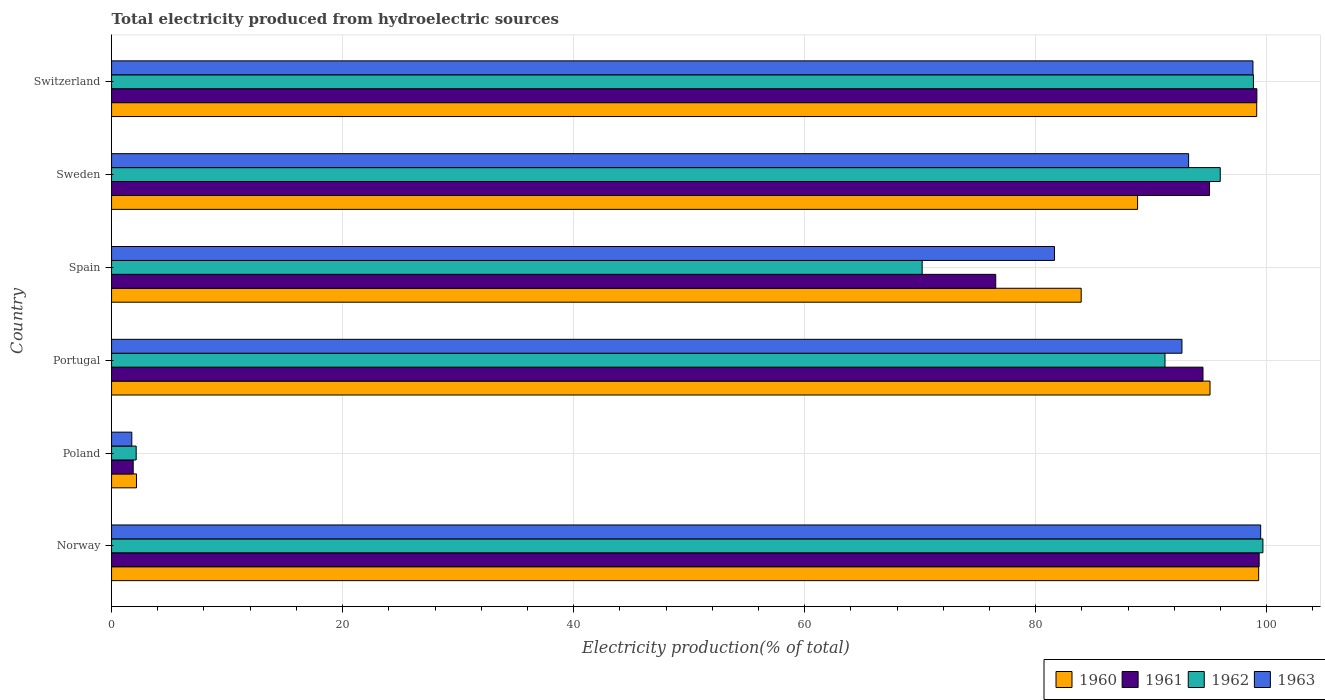How many groups of bars are there?
Ensure brevity in your answer.  6. How many bars are there on the 3rd tick from the top?
Give a very brief answer. 4. What is the label of the 2nd group of bars from the top?
Offer a terse response. Sweden. In how many cases, is the number of bars for a given country not equal to the number of legend labels?
Offer a very short reply. 0. What is the total electricity produced in 1962 in Poland?
Your answer should be compact. 2.13. Across all countries, what is the maximum total electricity produced in 1961?
Your answer should be compact. 99.34. Across all countries, what is the minimum total electricity produced in 1961?
Keep it short and to the point. 1.87. In which country was the total electricity produced in 1962 maximum?
Offer a very short reply. Norway. What is the total total electricity produced in 1961 in the graph?
Provide a short and direct response. 466.43. What is the difference between the total electricity produced in 1962 in Sweden and that in Switzerland?
Your answer should be very brief. -2.87. What is the difference between the total electricity produced in 1962 in Poland and the total electricity produced in 1960 in Spain?
Offer a terse response. -81.8. What is the average total electricity produced in 1961 per country?
Make the answer very short. 77.74. What is the difference between the total electricity produced in 1961 and total electricity produced in 1963 in Spain?
Your answer should be compact. -5.09. In how many countries, is the total electricity produced in 1960 greater than 96 %?
Ensure brevity in your answer.  2. What is the ratio of the total electricity produced in 1963 in Norway to that in Switzerland?
Make the answer very short. 1.01. Is the total electricity produced in 1962 in Poland less than that in Spain?
Give a very brief answer. Yes. What is the difference between the highest and the second highest total electricity produced in 1963?
Keep it short and to the point. 0.67. What is the difference between the highest and the lowest total electricity produced in 1962?
Keep it short and to the point. 97.54. Is it the case that in every country, the sum of the total electricity produced in 1960 and total electricity produced in 1961 is greater than the sum of total electricity produced in 1963 and total electricity produced in 1962?
Give a very brief answer. No. What does the 3rd bar from the bottom in Portugal represents?
Provide a succinct answer. 1962. How many bars are there?
Your answer should be compact. 24. Are all the bars in the graph horizontal?
Give a very brief answer. Yes. What is the difference between two consecutive major ticks on the X-axis?
Provide a succinct answer. 20. Does the graph contain any zero values?
Provide a succinct answer. No. Does the graph contain grids?
Offer a very short reply. Yes. How many legend labels are there?
Make the answer very short. 4. What is the title of the graph?
Your answer should be very brief. Total electricity produced from hydroelectric sources. Does "2011" appear as one of the legend labels in the graph?
Offer a terse response. No. What is the Electricity production(% of total) of 1960 in Norway?
Keep it short and to the point. 99.3. What is the Electricity production(% of total) in 1961 in Norway?
Provide a succinct answer. 99.34. What is the Electricity production(% of total) of 1962 in Norway?
Your answer should be very brief. 99.67. What is the Electricity production(% of total) in 1963 in Norway?
Keep it short and to the point. 99.47. What is the Electricity production(% of total) in 1960 in Poland?
Offer a terse response. 2.16. What is the Electricity production(% of total) in 1961 in Poland?
Ensure brevity in your answer.  1.87. What is the Electricity production(% of total) of 1962 in Poland?
Provide a succinct answer. 2.13. What is the Electricity production(% of total) in 1963 in Poland?
Ensure brevity in your answer.  1.75. What is the Electricity production(% of total) in 1960 in Portugal?
Provide a succinct answer. 95.09. What is the Electricity production(% of total) of 1961 in Portugal?
Provide a succinct answer. 94.48. What is the Electricity production(% of total) in 1962 in Portugal?
Your answer should be compact. 91.19. What is the Electricity production(% of total) of 1963 in Portugal?
Make the answer very short. 92.66. What is the Electricity production(% of total) in 1960 in Spain?
Offer a terse response. 83.94. What is the Electricity production(% of total) of 1961 in Spain?
Your answer should be compact. 76.54. What is the Electricity production(% of total) of 1962 in Spain?
Offer a very short reply. 70.17. What is the Electricity production(% of total) in 1963 in Spain?
Your answer should be very brief. 81.63. What is the Electricity production(% of total) of 1960 in Sweden?
Give a very brief answer. 88.82. What is the Electricity production(% of total) in 1961 in Sweden?
Offer a very short reply. 95.05. What is the Electricity production(% of total) in 1962 in Sweden?
Provide a short and direct response. 95.98. What is the Electricity production(% of total) in 1963 in Sweden?
Ensure brevity in your answer.  93.24. What is the Electricity production(% of total) in 1960 in Switzerland?
Ensure brevity in your answer.  99.13. What is the Electricity production(% of total) in 1961 in Switzerland?
Ensure brevity in your answer.  99.15. What is the Electricity production(% of total) of 1962 in Switzerland?
Your answer should be very brief. 98.85. What is the Electricity production(% of total) of 1963 in Switzerland?
Offer a very short reply. 98.81. Across all countries, what is the maximum Electricity production(% of total) of 1960?
Make the answer very short. 99.3. Across all countries, what is the maximum Electricity production(% of total) in 1961?
Keep it short and to the point. 99.34. Across all countries, what is the maximum Electricity production(% of total) in 1962?
Keep it short and to the point. 99.67. Across all countries, what is the maximum Electricity production(% of total) of 1963?
Provide a succinct answer. 99.47. Across all countries, what is the minimum Electricity production(% of total) of 1960?
Provide a succinct answer. 2.16. Across all countries, what is the minimum Electricity production(% of total) of 1961?
Make the answer very short. 1.87. Across all countries, what is the minimum Electricity production(% of total) in 1962?
Your answer should be compact. 2.13. Across all countries, what is the minimum Electricity production(% of total) of 1963?
Your answer should be compact. 1.75. What is the total Electricity production(% of total) in 1960 in the graph?
Provide a succinct answer. 468.44. What is the total Electricity production(% of total) of 1961 in the graph?
Your response must be concise. 466.43. What is the total Electricity production(% of total) in 1962 in the graph?
Give a very brief answer. 457.99. What is the total Electricity production(% of total) in 1963 in the graph?
Offer a terse response. 467.56. What is the difference between the Electricity production(% of total) of 1960 in Norway and that in Poland?
Offer a very short reply. 97.14. What is the difference between the Electricity production(% of total) in 1961 in Norway and that in Poland?
Your response must be concise. 97.47. What is the difference between the Electricity production(% of total) in 1962 in Norway and that in Poland?
Offer a very short reply. 97.54. What is the difference between the Electricity production(% of total) in 1963 in Norway and that in Poland?
Your answer should be very brief. 97.72. What is the difference between the Electricity production(% of total) of 1960 in Norway and that in Portugal?
Your response must be concise. 4.21. What is the difference between the Electricity production(% of total) of 1961 in Norway and that in Portugal?
Keep it short and to the point. 4.86. What is the difference between the Electricity production(% of total) of 1962 in Norway and that in Portugal?
Your response must be concise. 8.48. What is the difference between the Electricity production(% of total) in 1963 in Norway and that in Portugal?
Keep it short and to the point. 6.81. What is the difference between the Electricity production(% of total) of 1960 in Norway and that in Spain?
Ensure brevity in your answer.  15.36. What is the difference between the Electricity production(% of total) in 1961 in Norway and that in Spain?
Offer a terse response. 22.8. What is the difference between the Electricity production(% of total) in 1962 in Norway and that in Spain?
Your response must be concise. 29.5. What is the difference between the Electricity production(% of total) of 1963 in Norway and that in Spain?
Your answer should be very brief. 17.85. What is the difference between the Electricity production(% of total) of 1960 in Norway and that in Sweden?
Ensure brevity in your answer.  10.48. What is the difference between the Electricity production(% of total) in 1961 in Norway and that in Sweden?
Provide a short and direct response. 4.29. What is the difference between the Electricity production(% of total) in 1962 in Norway and that in Sweden?
Make the answer very short. 3.69. What is the difference between the Electricity production(% of total) in 1963 in Norway and that in Sweden?
Provide a short and direct response. 6.24. What is the difference between the Electricity production(% of total) in 1960 in Norway and that in Switzerland?
Give a very brief answer. 0.17. What is the difference between the Electricity production(% of total) in 1961 in Norway and that in Switzerland?
Your answer should be very brief. 0.2. What is the difference between the Electricity production(% of total) in 1962 in Norway and that in Switzerland?
Offer a very short reply. 0.82. What is the difference between the Electricity production(% of total) in 1963 in Norway and that in Switzerland?
Make the answer very short. 0.67. What is the difference between the Electricity production(% of total) in 1960 in Poland and that in Portugal?
Your answer should be compact. -92.93. What is the difference between the Electricity production(% of total) of 1961 in Poland and that in Portugal?
Make the answer very short. -92.61. What is the difference between the Electricity production(% of total) in 1962 in Poland and that in Portugal?
Give a very brief answer. -89.06. What is the difference between the Electricity production(% of total) of 1963 in Poland and that in Portugal?
Your response must be concise. -90.91. What is the difference between the Electricity production(% of total) of 1960 in Poland and that in Spain?
Provide a succinct answer. -81.78. What is the difference between the Electricity production(% of total) of 1961 in Poland and that in Spain?
Your response must be concise. -74.67. What is the difference between the Electricity production(% of total) in 1962 in Poland and that in Spain?
Offer a terse response. -68.04. What is the difference between the Electricity production(% of total) in 1963 in Poland and that in Spain?
Offer a terse response. -79.88. What is the difference between the Electricity production(% of total) of 1960 in Poland and that in Sweden?
Offer a terse response. -86.66. What is the difference between the Electricity production(% of total) in 1961 in Poland and that in Sweden?
Make the answer very short. -93.17. What is the difference between the Electricity production(% of total) of 1962 in Poland and that in Sweden?
Offer a terse response. -93.84. What is the difference between the Electricity production(% of total) of 1963 in Poland and that in Sweden?
Offer a terse response. -91.48. What is the difference between the Electricity production(% of total) of 1960 in Poland and that in Switzerland?
Keep it short and to the point. -96.97. What is the difference between the Electricity production(% of total) of 1961 in Poland and that in Switzerland?
Offer a terse response. -97.27. What is the difference between the Electricity production(% of total) of 1962 in Poland and that in Switzerland?
Make the answer very short. -96.71. What is the difference between the Electricity production(% of total) of 1963 in Poland and that in Switzerland?
Your answer should be very brief. -97.06. What is the difference between the Electricity production(% of total) of 1960 in Portugal and that in Spain?
Ensure brevity in your answer.  11.15. What is the difference between the Electricity production(% of total) of 1961 in Portugal and that in Spain?
Ensure brevity in your answer.  17.94. What is the difference between the Electricity production(% of total) of 1962 in Portugal and that in Spain?
Provide a short and direct response. 21.02. What is the difference between the Electricity production(% of total) of 1963 in Portugal and that in Spain?
Give a very brief answer. 11.03. What is the difference between the Electricity production(% of total) in 1960 in Portugal and that in Sweden?
Offer a terse response. 6.27. What is the difference between the Electricity production(% of total) in 1961 in Portugal and that in Sweden?
Offer a terse response. -0.57. What is the difference between the Electricity production(% of total) of 1962 in Portugal and that in Sweden?
Your response must be concise. -4.78. What is the difference between the Electricity production(% of total) in 1963 in Portugal and that in Sweden?
Give a very brief answer. -0.58. What is the difference between the Electricity production(% of total) of 1960 in Portugal and that in Switzerland?
Ensure brevity in your answer.  -4.04. What is the difference between the Electricity production(% of total) in 1961 in Portugal and that in Switzerland?
Make the answer very short. -4.67. What is the difference between the Electricity production(% of total) of 1962 in Portugal and that in Switzerland?
Ensure brevity in your answer.  -7.65. What is the difference between the Electricity production(% of total) in 1963 in Portugal and that in Switzerland?
Offer a terse response. -6.15. What is the difference between the Electricity production(% of total) in 1960 in Spain and that in Sweden?
Give a very brief answer. -4.88. What is the difference between the Electricity production(% of total) in 1961 in Spain and that in Sweden?
Your answer should be compact. -18.51. What is the difference between the Electricity production(% of total) of 1962 in Spain and that in Sweden?
Keep it short and to the point. -25.8. What is the difference between the Electricity production(% of total) of 1963 in Spain and that in Sweden?
Offer a very short reply. -11.61. What is the difference between the Electricity production(% of total) in 1960 in Spain and that in Switzerland?
Provide a succinct answer. -15.19. What is the difference between the Electricity production(% of total) in 1961 in Spain and that in Switzerland?
Offer a very short reply. -22.61. What is the difference between the Electricity production(% of total) of 1962 in Spain and that in Switzerland?
Keep it short and to the point. -28.67. What is the difference between the Electricity production(% of total) in 1963 in Spain and that in Switzerland?
Make the answer very short. -17.18. What is the difference between the Electricity production(% of total) in 1960 in Sweden and that in Switzerland?
Provide a succinct answer. -10.31. What is the difference between the Electricity production(% of total) of 1961 in Sweden and that in Switzerland?
Make the answer very short. -4.1. What is the difference between the Electricity production(% of total) of 1962 in Sweden and that in Switzerland?
Your response must be concise. -2.87. What is the difference between the Electricity production(% of total) of 1963 in Sweden and that in Switzerland?
Provide a short and direct response. -5.57. What is the difference between the Electricity production(% of total) in 1960 in Norway and the Electricity production(% of total) in 1961 in Poland?
Give a very brief answer. 97.43. What is the difference between the Electricity production(% of total) in 1960 in Norway and the Electricity production(% of total) in 1962 in Poland?
Provide a succinct answer. 97.17. What is the difference between the Electricity production(% of total) of 1960 in Norway and the Electricity production(% of total) of 1963 in Poland?
Provide a succinct answer. 97.55. What is the difference between the Electricity production(% of total) of 1961 in Norway and the Electricity production(% of total) of 1962 in Poland?
Offer a terse response. 97.21. What is the difference between the Electricity production(% of total) of 1961 in Norway and the Electricity production(% of total) of 1963 in Poland?
Offer a very short reply. 97.59. What is the difference between the Electricity production(% of total) of 1962 in Norway and the Electricity production(% of total) of 1963 in Poland?
Your answer should be compact. 97.92. What is the difference between the Electricity production(% of total) of 1960 in Norway and the Electricity production(% of total) of 1961 in Portugal?
Give a very brief answer. 4.82. What is the difference between the Electricity production(% of total) in 1960 in Norway and the Electricity production(% of total) in 1962 in Portugal?
Give a very brief answer. 8.11. What is the difference between the Electricity production(% of total) in 1960 in Norway and the Electricity production(% of total) in 1963 in Portugal?
Provide a short and direct response. 6.64. What is the difference between the Electricity production(% of total) of 1961 in Norway and the Electricity production(% of total) of 1962 in Portugal?
Your response must be concise. 8.15. What is the difference between the Electricity production(% of total) in 1961 in Norway and the Electricity production(% of total) in 1963 in Portugal?
Provide a succinct answer. 6.68. What is the difference between the Electricity production(% of total) of 1962 in Norway and the Electricity production(% of total) of 1963 in Portugal?
Make the answer very short. 7.01. What is the difference between the Electricity production(% of total) in 1960 in Norway and the Electricity production(% of total) in 1961 in Spain?
Offer a terse response. 22.76. What is the difference between the Electricity production(% of total) of 1960 in Norway and the Electricity production(% of total) of 1962 in Spain?
Provide a succinct answer. 29.13. What is the difference between the Electricity production(% of total) of 1960 in Norway and the Electricity production(% of total) of 1963 in Spain?
Provide a succinct answer. 17.67. What is the difference between the Electricity production(% of total) of 1961 in Norway and the Electricity production(% of total) of 1962 in Spain?
Offer a very short reply. 29.17. What is the difference between the Electricity production(% of total) of 1961 in Norway and the Electricity production(% of total) of 1963 in Spain?
Give a very brief answer. 17.72. What is the difference between the Electricity production(% of total) of 1962 in Norway and the Electricity production(% of total) of 1963 in Spain?
Make the answer very short. 18.04. What is the difference between the Electricity production(% of total) of 1960 in Norway and the Electricity production(% of total) of 1961 in Sweden?
Give a very brief answer. 4.25. What is the difference between the Electricity production(% of total) in 1960 in Norway and the Electricity production(% of total) in 1962 in Sweden?
Ensure brevity in your answer.  3.33. What is the difference between the Electricity production(% of total) of 1960 in Norway and the Electricity production(% of total) of 1963 in Sweden?
Offer a very short reply. 6.06. What is the difference between the Electricity production(% of total) in 1961 in Norway and the Electricity production(% of total) in 1962 in Sweden?
Provide a succinct answer. 3.37. What is the difference between the Electricity production(% of total) in 1961 in Norway and the Electricity production(% of total) in 1963 in Sweden?
Your answer should be compact. 6.11. What is the difference between the Electricity production(% of total) in 1962 in Norway and the Electricity production(% of total) in 1963 in Sweden?
Your response must be concise. 6.43. What is the difference between the Electricity production(% of total) of 1960 in Norway and the Electricity production(% of total) of 1961 in Switzerland?
Your answer should be compact. 0.15. What is the difference between the Electricity production(% of total) of 1960 in Norway and the Electricity production(% of total) of 1962 in Switzerland?
Make the answer very short. 0.45. What is the difference between the Electricity production(% of total) of 1960 in Norway and the Electricity production(% of total) of 1963 in Switzerland?
Give a very brief answer. 0.49. What is the difference between the Electricity production(% of total) of 1961 in Norway and the Electricity production(% of total) of 1962 in Switzerland?
Your response must be concise. 0.5. What is the difference between the Electricity production(% of total) of 1961 in Norway and the Electricity production(% of total) of 1963 in Switzerland?
Your response must be concise. 0.54. What is the difference between the Electricity production(% of total) in 1962 in Norway and the Electricity production(% of total) in 1963 in Switzerland?
Your answer should be compact. 0.86. What is the difference between the Electricity production(% of total) of 1960 in Poland and the Electricity production(% of total) of 1961 in Portugal?
Your answer should be very brief. -92.32. What is the difference between the Electricity production(% of total) in 1960 in Poland and the Electricity production(% of total) in 1962 in Portugal?
Your answer should be compact. -89.03. What is the difference between the Electricity production(% of total) in 1960 in Poland and the Electricity production(% of total) in 1963 in Portugal?
Provide a short and direct response. -90.5. What is the difference between the Electricity production(% of total) of 1961 in Poland and the Electricity production(% of total) of 1962 in Portugal?
Make the answer very short. -89.32. What is the difference between the Electricity production(% of total) in 1961 in Poland and the Electricity production(% of total) in 1963 in Portugal?
Offer a very short reply. -90.79. What is the difference between the Electricity production(% of total) of 1962 in Poland and the Electricity production(% of total) of 1963 in Portugal?
Your answer should be compact. -90.53. What is the difference between the Electricity production(% of total) of 1960 in Poland and the Electricity production(% of total) of 1961 in Spain?
Ensure brevity in your answer.  -74.38. What is the difference between the Electricity production(% of total) of 1960 in Poland and the Electricity production(% of total) of 1962 in Spain?
Your answer should be very brief. -68.01. What is the difference between the Electricity production(% of total) of 1960 in Poland and the Electricity production(% of total) of 1963 in Spain?
Provide a succinct answer. -79.47. What is the difference between the Electricity production(% of total) of 1961 in Poland and the Electricity production(% of total) of 1962 in Spain?
Give a very brief answer. -68.3. What is the difference between the Electricity production(% of total) of 1961 in Poland and the Electricity production(% of total) of 1963 in Spain?
Offer a very short reply. -79.75. What is the difference between the Electricity production(% of total) of 1962 in Poland and the Electricity production(% of total) of 1963 in Spain?
Provide a succinct answer. -79.5. What is the difference between the Electricity production(% of total) in 1960 in Poland and the Electricity production(% of total) in 1961 in Sweden?
Keep it short and to the point. -92.89. What is the difference between the Electricity production(% of total) of 1960 in Poland and the Electricity production(% of total) of 1962 in Sweden?
Your answer should be very brief. -93.82. What is the difference between the Electricity production(% of total) in 1960 in Poland and the Electricity production(% of total) in 1963 in Sweden?
Make the answer very short. -91.08. What is the difference between the Electricity production(% of total) in 1961 in Poland and the Electricity production(% of total) in 1962 in Sweden?
Give a very brief answer. -94.1. What is the difference between the Electricity production(% of total) of 1961 in Poland and the Electricity production(% of total) of 1963 in Sweden?
Provide a short and direct response. -91.36. What is the difference between the Electricity production(% of total) of 1962 in Poland and the Electricity production(% of total) of 1963 in Sweden?
Offer a terse response. -91.1. What is the difference between the Electricity production(% of total) in 1960 in Poland and the Electricity production(% of total) in 1961 in Switzerland?
Provide a succinct answer. -96.99. What is the difference between the Electricity production(% of total) in 1960 in Poland and the Electricity production(% of total) in 1962 in Switzerland?
Ensure brevity in your answer.  -96.69. What is the difference between the Electricity production(% of total) in 1960 in Poland and the Electricity production(% of total) in 1963 in Switzerland?
Provide a short and direct response. -96.65. What is the difference between the Electricity production(% of total) of 1961 in Poland and the Electricity production(% of total) of 1962 in Switzerland?
Your response must be concise. -96.97. What is the difference between the Electricity production(% of total) in 1961 in Poland and the Electricity production(% of total) in 1963 in Switzerland?
Keep it short and to the point. -96.93. What is the difference between the Electricity production(% of total) in 1962 in Poland and the Electricity production(% of total) in 1963 in Switzerland?
Offer a terse response. -96.67. What is the difference between the Electricity production(% of total) in 1960 in Portugal and the Electricity production(% of total) in 1961 in Spain?
Keep it short and to the point. 18.55. What is the difference between the Electricity production(% of total) in 1960 in Portugal and the Electricity production(% of total) in 1962 in Spain?
Give a very brief answer. 24.92. What is the difference between the Electricity production(% of total) of 1960 in Portugal and the Electricity production(% of total) of 1963 in Spain?
Offer a very short reply. 13.46. What is the difference between the Electricity production(% of total) in 1961 in Portugal and the Electricity production(% of total) in 1962 in Spain?
Provide a succinct answer. 24.31. What is the difference between the Electricity production(% of total) of 1961 in Portugal and the Electricity production(% of total) of 1963 in Spain?
Your answer should be compact. 12.85. What is the difference between the Electricity production(% of total) in 1962 in Portugal and the Electricity production(% of total) in 1963 in Spain?
Provide a short and direct response. 9.57. What is the difference between the Electricity production(% of total) in 1960 in Portugal and the Electricity production(% of total) in 1961 in Sweden?
Make the answer very short. 0.04. What is the difference between the Electricity production(% of total) in 1960 in Portugal and the Electricity production(% of total) in 1962 in Sweden?
Ensure brevity in your answer.  -0.89. What is the difference between the Electricity production(% of total) of 1960 in Portugal and the Electricity production(% of total) of 1963 in Sweden?
Your answer should be very brief. 1.85. What is the difference between the Electricity production(% of total) of 1961 in Portugal and the Electricity production(% of total) of 1962 in Sweden?
Make the answer very short. -1.49. What is the difference between the Electricity production(% of total) in 1961 in Portugal and the Electricity production(% of total) in 1963 in Sweden?
Offer a very short reply. 1.24. What is the difference between the Electricity production(% of total) of 1962 in Portugal and the Electricity production(% of total) of 1963 in Sweden?
Keep it short and to the point. -2.04. What is the difference between the Electricity production(% of total) in 1960 in Portugal and the Electricity production(% of total) in 1961 in Switzerland?
Provide a short and direct response. -4.06. What is the difference between the Electricity production(% of total) in 1960 in Portugal and the Electricity production(% of total) in 1962 in Switzerland?
Provide a succinct answer. -3.76. What is the difference between the Electricity production(% of total) in 1960 in Portugal and the Electricity production(% of total) in 1963 in Switzerland?
Offer a very short reply. -3.72. What is the difference between the Electricity production(% of total) in 1961 in Portugal and the Electricity production(% of total) in 1962 in Switzerland?
Keep it short and to the point. -4.37. What is the difference between the Electricity production(% of total) in 1961 in Portugal and the Electricity production(% of total) in 1963 in Switzerland?
Ensure brevity in your answer.  -4.33. What is the difference between the Electricity production(% of total) in 1962 in Portugal and the Electricity production(% of total) in 1963 in Switzerland?
Offer a terse response. -7.61. What is the difference between the Electricity production(% of total) in 1960 in Spain and the Electricity production(% of total) in 1961 in Sweden?
Offer a terse response. -11.11. What is the difference between the Electricity production(% of total) of 1960 in Spain and the Electricity production(% of total) of 1962 in Sweden?
Make the answer very short. -12.04. What is the difference between the Electricity production(% of total) of 1960 in Spain and the Electricity production(% of total) of 1963 in Sweden?
Ensure brevity in your answer.  -9.3. What is the difference between the Electricity production(% of total) of 1961 in Spain and the Electricity production(% of total) of 1962 in Sweden?
Your answer should be compact. -19.44. What is the difference between the Electricity production(% of total) in 1961 in Spain and the Electricity production(% of total) in 1963 in Sweden?
Your response must be concise. -16.7. What is the difference between the Electricity production(% of total) of 1962 in Spain and the Electricity production(% of total) of 1963 in Sweden?
Offer a terse response. -23.06. What is the difference between the Electricity production(% of total) of 1960 in Spain and the Electricity production(% of total) of 1961 in Switzerland?
Your response must be concise. -15.21. What is the difference between the Electricity production(% of total) in 1960 in Spain and the Electricity production(% of total) in 1962 in Switzerland?
Make the answer very short. -14.91. What is the difference between the Electricity production(% of total) of 1960 in Spain and the Electricity production(% of total) of 1963 in Switzerland?
Provide a short and direct response. -14.87. What is the difference between the Electricity production(% of total) in 1961 in Spain and the Electricity production(% of total) in 1962 in Switzerland?
Make the answer very short. -22.31. What is the difference between the Electricity production(% of total) in 1961 in Spain and the Electricity production(% of total) in 1963 in Switzerland?
Offer a very short reply. -22.27. What is the difference between the Electricity production(% of total) of 1962 in Spain and the Electricity production(% of total) of 1963 in Switzerland?
Your response must be concise. -28.63. What is the difference between the Electricity production(% of total) of 1960 in Sweden and the Electricity production(% of total) of 1961 in Switzerland?
Offer a terse response. -10.33. What is the difference between the Electricity production(% of total) of 1960 in Sweden and the Electricity production(% of total) of 1962 in Switzerland?
Offer a very short reply. -10.03. What is the difference between the Electricity production(% of total) in 1960 in Sweden and the Electricity production(% of total) in 1963 in Switzerland?
Provide a succinct answer. -9.99. What is the difference between the Electricity production(% of total) of 1961 in Sweden and the Electricity production(% of total) of 1962 in Switzerland?
Give a very brief answer. -3.8. What is the difference between the Electricity production(% of total) in 1961 in Sweden and the Electricity production(% of total) in 1963 in Switzerland?
Keep it short and to the point. -3.76. What is the difference between the Electricity production(% of total) in 1962 in Sweden and the Electricity production(% of total) in 1963 in Switzerland?
Keep it short and to the point. -2.83. What is the average Electricity production(% of total) in 1960 per country?
Your answer should be compact. 78.07. What is the average Electricity production(% of total) in 1961 per country?
Ensure brevity in your answer.  77.74. What is the average Electricity production(% of total) in 1962 per country?
Your answer should be compact. 76.33. What is the average Electricity production(% of total) of 1963 per country?
Keep it short and to the point. 77.93. What is the difference between the Electricity production(% of total) in 1960 and Electricity production(% of total) in 1961 in Norway?
Ensure brevity in your answer.  -0.04. What is the difference between the Electricity production(% of total) in 1960 and Electricity production(% of total) in 1962 in Norway?
Provide a short and direct response. -0.37. What is the difference between the Electricity production(% of total) of 1960 and Electricity production(% of total) of 1963 in Norway?
Ensure brevity in your answer.  -0.17. What is the difference between the Electricity production(% of total) of 1961 and Electricity production(% of total) of 1962 in Norway?
Ensure brevity in your answer.  -0.33. What is the difference between the Electricity production(% of total) of 1961 and Electricity production(% of total) of 1963 in Norway?
Your response must be concise. -0.13. What is the difference between the Electricity production(% of total) of 1962 and Electricity production(% of total) of 1963 in Norway?
Keep it short and to the point. 0.19. What is the difference between the Electricity production(% of total) in 1960 and Electricity production(% of total) in 1961 in Poland?
Provide a short and direct response. 0.28. What is the difference between the Electricity production(% of total) in 1960 and Electricity production(% of total) in 1962 in Poland?
Your answer should be very brief. 0.03. What is the difference between the Electricity production(% of total) of 1960 and Electricity production(% of total) of 1963 in Poland?
Keep it short and to the point. 0.41. What is the difference between the Electricity production(% of total) in 1961 and Electricity production(% of total) in 1962 in Poland?
Your answer should be very brief. -0.26. What is the difference between the Electricity production(% of total) in 1961 and Electricity production(% of total) in 1963 in Poland?
Provide a short and direct response. 0.12. What is the difference between the Electricity production(% of total) in 1962 and Electricity production(% of total) in 1963 in Poland?
Keep it short and to the point. 0.38. What is the difference between the Electricity production(% of total) of 1960 and Electricity production(% of total) of 1961 in Portugal?
Offer a very short reply. 0.61. What is the difference between the Electricity production(% of total) of 1960 and Electricity production(% of total) of 1962 in Portugal?
Provide a short and direct response. 3.9. What is the difference between the Electricity production(% of total) in 1960 and Electricity production(% of total) in 1963 in Portugal?
Keep it short and to the point. 2.43. What is the difference between the Electricity production(% of total) of 1961 and Electricity production(% of total) of 1962 in Portugal?
Ensure brevity in your answer.  3.29. What is the difference between the Electricity production(% of total) in 1961 and Electricity production(% of total) in 1963 in Portugal?
Ensure brevity in your answer.  1.82. What is the difference between the Electricity production(% of total) in 1962 and Electricity production(% of total) in 1963 in Portugal?
Give a very brief answer. -1.47. What is the difference between the Electricity production(% of total) in 1960 and Electricity production(% of total) in 1961 in Spain?
Provide a succinct answer. 7.4. What is the difference between the Electricity production(% of total) in 1960 and Electricity production(% of total) in 1962 in Spain?
Give a very brief answer. 13.76. What is the difference between the Electricity production(% of total) of 1960 and Electricity production(% of total) of 1963 in Spain?
Provide a short and direct response. 2.31. What is the difference between the Electricity production(% of total) of 1961 and Electricity production(% of total) of 1962 in Spain?
Give a very brief answer. 6.37. What is the difference between the Electricity production(% of total) of 1961 and Electricity production(% of total) of 1963 in Spain?
Ensure brevity in your answer.  -5.09. What is the difference between the Electricity production(% of total) of 1962 and Electricity production(% of total) of 1963 in Spain?
Keep it short and to the point. -11.45. What is the difference between the Electricity production(% of total) in 1960 and Electricity production(% of total) in 1961 in Sweden?
Ensure brevity in your answer.  -6.23. What is the difference between the Electricity production(% of total) in 1960 and Electricity production(% of total) in 1962 in Sweden?
Offer a terse response. -7.16. What is the difference between the Electricity production(% of total) in 1960 and Electricity production(% of total) in 1963 in Sweden?
Ensure brevity in your answer.  -4.42. What is the difference between the Electricity production(% of total) of 1961 and Electricity production(% of total) of 1962 in Sweden?
Your answer should be very brief. -0.93. What is the difference between the Electricity production(% of total) of 1961 and Electricity production(% of total) of 1963 in Sweden?
Offer a very short reply. 1.81. What is the difference between the Electricity production(% of total) of 1962 and Electricity production(% of total) of 1963 in Sweden?
Ensure brevity in your answer.  2.74. What is the difference between the Electricity production(% of total) in 1960 and Electricity production(% of total) in 1961 in Switzerland?
Make the answer very short. -0.02. What is the difference between the Electricity production(% of total) in 1960 and Electricity production(% of total) in 1962 in Switzerland?
Offer a terse response. 0.28. What is the difference between the Electricity production(% of total) of 1960 and Electricity production(% of total) of 1963 in Switzerland?
Keep it short and to the point. 0.32. What is the difference between the Electricity production(% of total) in 1961 and Electricity production(% of total) in 1962 in Switzerland?
Provide a succinct answer. 0.3. What is the difference between the Electricity production(% of total) of 1961 and Electricity production(% of total) of 1963 in Switzerland?
Your answer should be compact. 0.34. What is the difference between the Electricity production(% of total) of 1962 and Electricity production(% of total) of 1963 in Switzerland?
Your response must be concise. 0.04. What is the ratio of the Electricity production(% of total) of 1960 in Norway to that in Poland?
Ensure brevity in your answer.  46.01. What is the ratio of the Electricity production(% of total) in 1961 in Norway to that in Poland?
Give a very brief answer. 53.03. What is the ratio of the Electricity production(% of total) in 1962 in Norway to that in Poland?
Provide a succinct answer. 46.75. What is the ratio of the Electricity production(% of total) in 1963 in Norway to that in Poland?
Provide a short and direct response. 56.8. What is the ratio of the Electricity production(% of total) in 1960 in Norway to that in Portugal?
Keep it short and to the point. 1.04. What is the ratio of the Electricity production(% of total) of 1961 in Norway to that in Portugal?
Your answer should be very brief. 1.05. What is the ratio of the Electricity production(% of total) in 1962 in Norway to that in Portugal?
Your answer should be compact. 1.09. What is the ratio of the Electricity production(% of total) in 1963 in Norway to that in Portugal?
Make the answer very short. 1.07. What is the ratio of the Electricity production(% of total) of 1960 in Norway to that in Spain?
Offer a terse response. 1.18. What is the ratio of the Electricity production(% of total) in 1961 in Norway to that in Spain?
Keep it short and to the point. 1.3. What is the ratio of the Electricity production(% of total) of 1962 in Norway to that in Spain?
Offer a very short reply. 1.42. What is the ratio of the Electricity production(% of total) of 1963 in Norway to that in Spain?
Give a very brief answer. 1.22. What is the ratio of the Electricity production(% of total) in 1960 in Norway to that in Sweden?
Your answer should be compact. 1.12. What is the ratio of the Electricity production(% of total) in 1961 in Norway to that in Sweden?
Your answer should be compact. 1.05. What is the ratio of the Electricity production(% of total) in 1962 in Norway to that in Sweden?
Your answer should be compact. 1.04. What is the ratio of the Electricity production(% of total) of 1963 in Norway to that in Sweden?
Keep it short and to the point. 1.07. What is the ratio of the Electricity production(% of total) in 1962 in Norway to that in Switzerland?
Your answer should be very brief. 1.01. What is the ratio of the Electricity production(% of total) of 1963 in Norway to that in Switzerland?
Make the answer very short. 1.01. What is the ratio of the Electricity production(% of total) of 1960 in Poland to that in Portugal?
Provide a short and direct response. 0.02. What is the ratio of the Electricity production(% of total) of 1961 in Poland to that in Portugal?
Offer a terse response. 0.02. What is the ratio of the Electricity production(% of total) of 1962 in Poland to that in Portugal?
Offer a terse response. 0.02. What is the ratio of the Electricity production(% of total) in 1963 in Poland to that in Portugal?
Give a very brief answer. 0.02. What is the ratio of the Electricity production(% of total) of 1960 in Poland to that in Spain?
Your answer should be very brief. 0.03. What is the ratio of the Electricity production(% of total) in 1961 in Poland to that in Spain?
Offer a very short reply. 0.02. What is the ratio of the Electricity production(% of total) of 1962 in Poland to that in Spain?
Keep it short and to the point. 0.03. What is the ratio of the Electricity production(% of total) of 1963 in Poland to that in Spain?
Offer a terse response. 0.02. What is the ratio of the Electricity production(% of total) in 1960 in Poland to that in Sweden?
Your response must be concise. 0.02. What is the ratio of the Electricity production(% of total) of 1961 in Poland to that in Sweden?
Keep it short and to the point. 0.02. What is the ratio of the Electricity production(% of total) in 1962 in Poland to that in Sweden?
Provide a short and direct response. 0.02. What is the ratio of the Electricity production(% of total) in 1963 in Poland to that in Sweden?
Provide a short and direct response. 0.02. What is the ratio of the Electricity production(% of total) in 1960 in Poland to that in Switzerland?
Ensure brevity in your answer.  0.02. What is the ratio of the Electricity production(% of total) in 1961 in Poland to that in Switzerland?
Offer a terse response. 0.02. What is the ratio of the Electricity production(% of total) in 1962 in Poland to that in Switzerland?
Provide a succinct answer. 0.02. What is the ratio of the Electricity production(% of total) in 1963 in Poland to that in Switzerland?
Provide a short and direct response. 0.02. What is the ratio of the Electricity production(% of total) in 1960 in Portugal to that in Spain?
Provide a short and direct response. 1.13. What is the ratio of the Electricity production(% of total) of 1961 in Portugal to that in Spain?
Offer a very short reply. 1.23. What is the ratio of the Electricity production(% of total) of 1962 in Portugal to that in Spain?
Offer a terse response. 1.3. What is the ratio of the Electricity production(% of total) in 1963 in Portugal to that in Spain?
Ensure brevity in your answer.  1.14. What is the ratio of the Electricity production(% of total) of 1960 in Portugal to that in Sweden?
Provide a succinct answer. 1.07. What is the ratio of the Electricity production(% of total) in 1961 in Portugal to that in Sweden?
Your answer should be compact. 0.99. What is the ratio of the Electricity production(% of total) of 1962 in Portugal to that in Sweden?
Give a very brief answer. 0.95. What is the ratio of the Electricity production(% of total) in 1963 in Portugal to that in Sweden?
Provide a succinct answer. 0.99. What is the ratio of the Electricity production(% of total) of 1960 in Portugal to that in Switzerland?
Provide a succinct answer. 0.96. What is the ratio of the Electricity production(% of total) of 1961 in Portugal to that in Switzerland?
Keep it short and to the point. 0.95. What is the ratio of the Electricity production(% of total) of 1962 in Portugal to that in Switzerland?
Keep it short and to the point. 0.92. What is the ratio of the Electricity production(% of total) in 1963 in Portugal to that in Switzerland?
Offer a terse response. 0.94. What is the ratio of the Electricity production(% of total) of 1960 in Spain to that in Sweden?
Offer a very short reply. 0.94. What is the ratio of the Electricity production(% of total) of 1961 in Spain to that in Sweden?
Your response must be concise. 0.81. What is the ratio of the Electricity production(% of total) in 1962 in Spain to that in Sweden?
Make the answer very short. 0.73. What is the ratio of the Electricity production(% of total) in 1963 in Spain to that in Sweden?
Keep it short and to the point. 0.88. What is the ratio of the Electricity production(% of total) of 1960 in Spain to that in Switzerland?
Your response must be concise. 0.85. What is the ratio of the Electricity production(% of total) of 1961 in Spain to that in Switzerland?
Keep it short and to the point. 0.77. What is the ratio of the Electricity production(% of total) of 1962 in Spain to that in Switzerland?
Your answer should be very brief. 0.71. What is the ratio of the Electricity production(% of total) of 1963 in Spain to that in Switzerland?
Make the answer very short. 0.83. What is the ratio of the Electricity production(% of total) of 1960 in Sweden to that in Switzerland?
Offer a very short reply. 0.9. What is the ratio of the Electricity production(% of total) in 1961 in Sweden to that in Switzerland?
Offer a very short reply. 0.96. What is the ratio of the Electricity production(% of total) of 1962 in Sweden to that in Switzerland?
Offer a very short reply. 0.97. What is the ratio of the Electricity production(% of total) of 1963 in Sweden to that in Switzerland?
Provide a succinct answer. 0.94. What is the difference between the highest and the second highest Electricity production(% of total) in 1960?
Your answer should be compact. 0.17. What is the difference between the highest and the second highest Electricity production(% of total) of 1961?
Provide a short and direct response. 0.2. What is the difference between the highest and the second highest Electricity production(% of total) in 1962?
Ensure brevity in your answer.  0.82. What is the difference between the highest and the second highest Electricity production(% of total) of 1963?
Give a very brief answer. 0.67. What is the difference between the highest and the lowest Electricity production(% of total) of 1960?
Ensure brevity in your answer.  97.14. What is the difference between the highest and the lowest Electricity production(% of total) in 1961?
Your answer should be very brief. 97.47. What is the difference between the highest and the lowest Electricity production(% of total) in 1962?
Offer a terse response. 97.54. What is the difference between the highest and the lowest Electricity production(% of total) in 1963?
Your response must be concise. 97.72. 